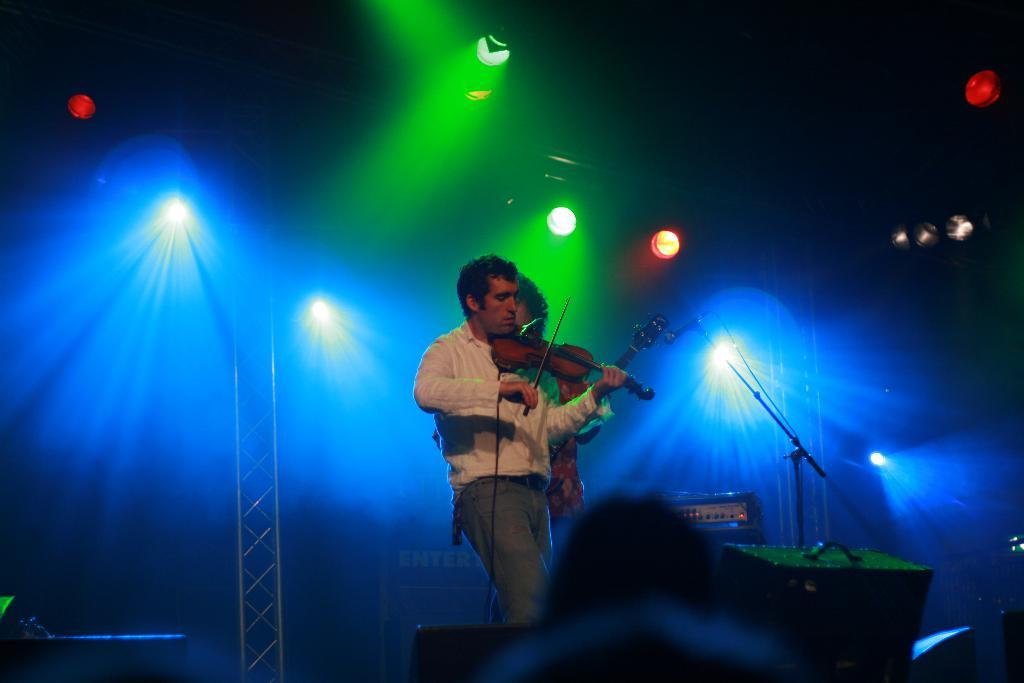What are the two persons in the foreground doing? The two persons in the foreground are playing musical instruments. Where is the scene taking place? The scene is on a stage. What can be seen in the background of the image? There are focus lights and metal rods in the background. What type of twig can be seen in the hands of the musicians? There is no twig present in the hands of the musicians; they are playing musical instruments. What toys are visible on the stage? There are no toys visible on the stage; the scene features two persons playing musical instruments. 